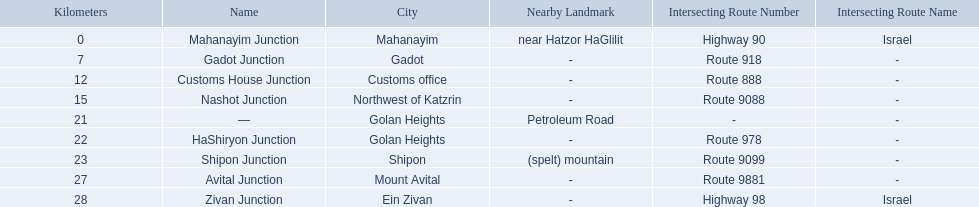What are all the are all the locations on the highway 91 (israel)? Mahanayim, near Hatzor HaGlilit, Gadot, Customs office, Northwest of Katzrin, Golan Heights, Golan Heights, Shipon (spelt) mountain, Mount Avital, Ein Zivan. What are the distance values in kilometers for ein zivan, gadot junction and shipon junction? 7, 23, 28. Which is the least distance away? 7. What is the name? Gadot Junction. 